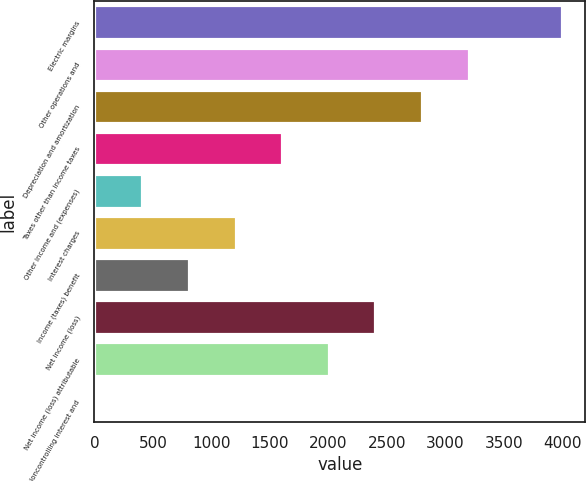Convert chart to OTSL. <chart><loc_0><loc_0><loc_500><loc_500><bar_chart><fcel>Electric margins<fcel>Other operations and<fcel>Depreciation and amortization<fcel>Taxes other than income taxes<fcel>Other income and (expenses)<fcel>Interest charges<fcel>Income (taxes) benefit<fcel>Net income (loss)<fcel>Net income (loss) attributable<fcel>Noncontrolling interest and<nl><fcel>3997<fcel>3200<fcel>2801.5<fcel>1606<fcel>410.5<fcel>1207.5<fcel>809<fcel>2403<fcel>2004.5<fcel>12<nl></chart> 